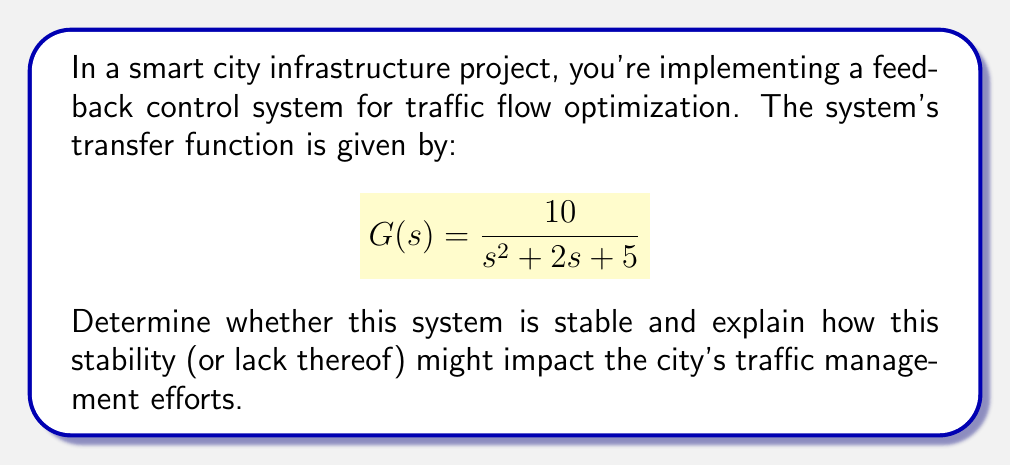Show me your answer to this math problem. To determine the stability of this feedback control system, we need to analyze the characteristic equation of the transfer function. The characteristic equation is the denominator of the transfer function set equal to zero:

$$s^2 + 2s + 5 = 0$$

For a second-order system like this, we can use the following steps:

1. Calculate the discriminant ($\Delta$) of the quadratic equation:
   $$\Delta = b^2 - 4ac$$
   where $a = 1$, $b = 2$, and $c = 5$
   
   $$\Delta = 2^2 - 4(1)(5) = 4 - 20 = -16$$

2. Since the discriminant is negative, the roots of the characteristic equation are complex conjugates.

3. For a second-order system with complex roots, the general form is:
   $$s^2 + 2\zeta\omega_n s + \omega_n^2 = 0$$
   where $\zeta$ is the damping ratio and $\omega_n$ is the natural frequency.

4. Comparing our equation to the general form:
   $$2\zeta\omega_n = 2$$
   $$\omega_n^2 = 5$$

5. Solving for $\omega_n$ and $\zeta$:
   $$\omega_n = \sqrt{5} \approx 2.236$$
   $$\zeta = \frac{2}{2\omega_n} = \frac{2}{2\sqrt{5}} \approx 0.447$$

6. For a second-order system to be stable, we need $\zeta > 0$ and $\omega_n > 0$, which is true in this case.

Therefore, the system is stable. This stability implies that the traffic management system will respond predictably to inputs and disturbances, eventually settling to a steady state. For city traffic management, this means:

1. The system can effectively adapt to changes in traffic patterns without becoming erratic.
2. Traffic flow will tend to normalize after disruptions, improving overall efficiency.
3. The system is less likely to overreact to temporary fluctuations, providing a more consistent experience for drivers.

However, the relatively low damping ratio ($\zeta < 1$) indicates that the system is underdamped, which may result in some oscillation before settling. In traffic terms, this could manifest as slight fluctuations in traffic flow before reaching optimal conditions.
Answer: The system is stable. The characteristic equation has complex conjugate roots with a positive damping ratio ($\zeta \approx 0.447$) and natural frequency ($\omega_n \approx 2.236$), indicating a stable, underdamped system that will respond predictably to inputs and disturbances in traffic flow. 